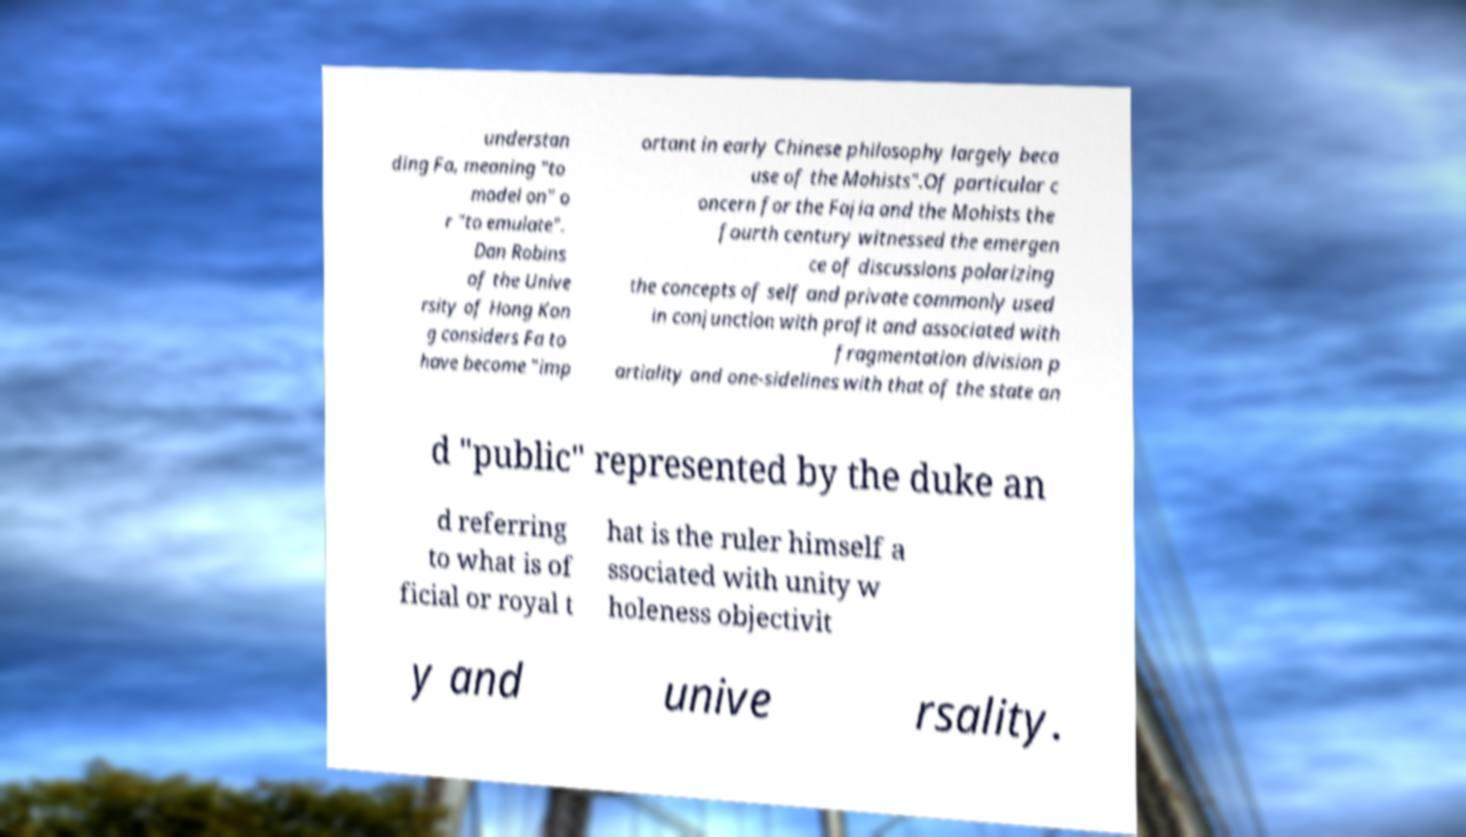I need the written content from this picture converted into text. Can you do that? understan ding Fa, meaning "to model on" o r "to emulate". Dan Robins of the Unive rsity of Hong Kon g considers Fa to have become "imp ortant in early Chinese philosophy largely beca use of the Mohists".Of particular c oncern for the Fajia and the Mohists the fourth century witnessed the emergen ce of discussions polarizing the concepts of self and private commonly used in conjunction with profit and associated with fragmentation division p artiality and one-sidelines with that of the state an d "public" represented by the duke an d referring to what is of ficial or royal t hat is the ruler himself a ssociated with unity w holeness objectivit y and unive rsality. 